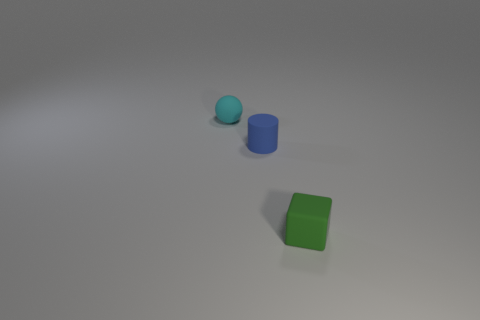Is the number of objects that are in front of the tiny blue rubber cylinder greater than the number of tiny green objects right of the tiny green cube?
Offer a terse response. Yes. How many other things are the same color as the sphere?
Make the answer very short. 0. What number of things are small cyan matte spheres or cyan metal balls?
Your answer should be very brief. 1. How many objects are cubes or tiny objects left of the tiny green object?
Keep it short and to the point. 3. Do the green block and the cylinder have the same material?
Ensure brevity in your answer.  Yes. What number of other things are made of the same material as the small cylinder?
Your response must be concise. 2. Is the number of tiny cyan matte balls greater than the number of cyan matte cylinders?
Offer a very short reply. Yes. Does the small rubber object that is behind the small blue rubber cylinder have the same shape as the blue object?
Ensure brevity in your answer.  No. Is the number of small green objects less than the number of red objects?
Provide a short and direct response. No. There is a block that is the same size as the blue cylinder; what is it made of?
Offer a very short reply. Rubber. 